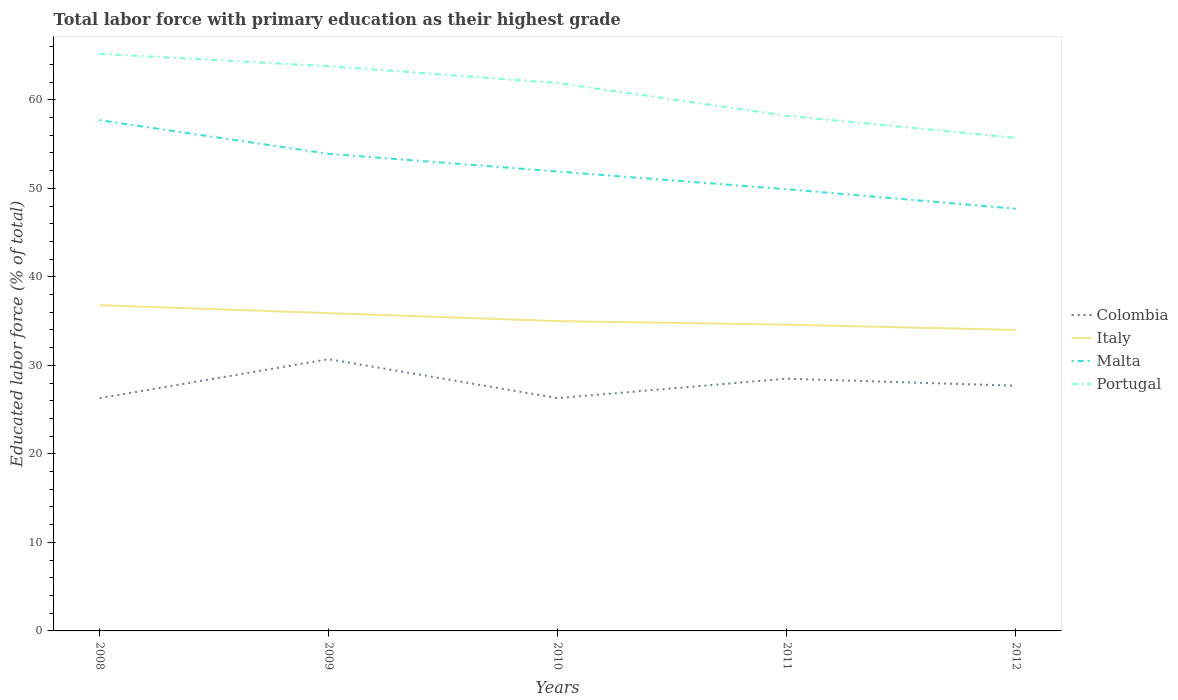How many different coloured lines are there?
Provide a succinct answer. 4. Is the number of lines equal to the number of legend labels?
Your response must be concise. Yes. What is the total percentage of total labor force with primary education in Italy in the graph?
Your response must be concise. 0.9. What is the difference between the highest and the second highest percentage of total labor force with primary education in Italy?
Give a very brief answer. 2.8. What is the difference between two consecutive major ticks on the Y-axis?
Your response must be concise. 10. Does the graph contain any zero values?
Your answer should be very brief. No. Does the graph contain grids?
Provide a succinct answer. No. Where does the legend appear in the graph?
Offer a terse response. Center right. How are the legend labels stacked?
Keep it short and to the point. Vertical. What is the title of the graph?
Keep it short and to the point. Total labor force with primary education as their highest grade. Does "Macao" appear as one of the legend labels in the graph?
Your response must be concise. No. What is the label or title of the Y-axis?
Offer a terse response. Educated labor force (% of total). What is the Educated labor force (% of total) of Colombia in 2008?
Ensure brevity in your answer.  26.3. What is the Educated labor force (% of total) in Italy in 2008?
Provide a short and direct response. 36.8. What is the Educated labor force (% of total) of Malta in 2008?
Offer a very short reply. 57.7. What is the Educated labor force (% of total) in Portugal in 2008?
Your answer should be compact. 65.2. What is the Educated labor force (% of total) of Colombia in 2009?
Ensure brevity in your answer.  30.7. What is the Educated labor force (% of total) of Italy in 2009?
Give a very brief answer. 35.9. What is the Educated labor force (% of total) of Malta in 2009?
Offer a very short reply. 53.9. What is the Educated labor force (% of total) in Portugal in 2009?
Your answer should be very brief. 63.8. What is the Educated labor force (% of total) of Colombia in 2010?
Your answer should be compact. 26.3. What is the Educated labor force (% of total) of Malta in 2010?
Make the answer very short. 51.9. What is the Educated labor force (% of total) of Portugal in 2010?
Provide a succinct answer. 61.9. What is the Educated labor force (% of total) in Italy in 2011?
Your answer should be very brief. 34.6. What is the Educated labor force (% of total) of Malta in 2011?
Make the answer very short. 49.9. What is the Educated labor force (% of total) of Portugal in 2011?
Keep it short and to the point. 58.2. What is the Educated labor force (% of total) in Colombia in 2012?
Your answer should be compact. 27.7. What is the Educated labor force (% of total) of Italy in 2012?
Your answer should be very brief. 34. What is the Educated labor force (% of total) of Malta in 2012?
Provide a short and direct response. 47.7. What is the Educated labor force (% of total) in Portugal in 2012?
Your answer should be compact. 55.7. Across all years, what is the maximum Educated labor force (% of total) of Colombia?
Your answer should be compact. 30.7. Across all years, what is the maximum Educated labor force (% of total) in Italy?
Offer a very short reply. 36.8. Across all years, what is the maximum Educated labor force (% of total) in Malta?
Give a very brief answer. 57.7. Across all years, what is the maximum Educated labor force (% of total) in Portugal?
Ensure brevity in your answer.  65.2. Across all years, what is the minimum Educated labor force (% of total) of Colombia?
Provide a succinct answer. 26.3. Across all years, what is the minimum Educated labor force (% of total) of Italy?
Provide a short and direct response. 34. Across all years, what is the minimum Educated labor force (% of total) of Malta?
Offer a very short reply. 47.7. Across all years, what is the minimum Educated labor force (% of total) in Portugal?
Make the answer very short. 55.7. What is the total Educated labor force (% of total) in Colombia in the graph?
Make the answer very short. 139.5. What is the total Educated labor force (% of total) in Italy in the graph?
Offer a terse response. 176.3. What is the total Educated labor force (% of total) of Malta in the graph?
Offer a terse response. 261.1. What is the total Educated labor force (% of total) of Portugal in the graph?
Make the answer very short. 304.8. What is the difference between the Educated labor force (% of total) in Portugal in 2008 and that in 2009?
Offer a very short reply. 1.4. What is the difference between the Educated labor force (% of total) in Colombia in 2008 and that in 2010?
Give a very brief answer. 0. What is the difference between the Educated labor force (% of total) of Malta in 2008 and that in 2010?
Your answer should be compact. 5.8. What is the difference between the Educated labor force (% of total) of Italy in 2008 and that in 2011?
Offer a terse response. 2.2. What is the difference between the Educated labor force (% of total) of Portugal in 2008 and that in 2011?
Your answer should be compact. 7. What is the difference between the Educated labor force (% of total) in Malta in 2008 and that in 2012?
Your answer should be compact. 10. What is the difference between the Educated labor force (% of total) in Portugal in 2008 and that in 2012?
Your response must be concise. 9.5. What is the difference between the Educated labor force (% of total) of Colombia in 2009 and that in 2010?
Ensure brevity in your answer.  4.4. What is the difference between the Educated labor force (% of total) of Italy in 2009 and that in 2010?
Give a very brief answer. 0.9. What is the difference between the Educated labor force (% of total) in Malta in 2009 and that in 2010?
Your answer should be very brief. 2. What is the difference between the Educated labor force (% of total) of Malta in 2009 and that in 2011?
Your answer should be compact. 4. What is the difference between the Educated labor force (% of total) in Italy in 2009 and that in 2012?
Your response must be concise. 1.9. What is the difference between the Educated labor force (% of total) of Portugal in 2009 and that in 2012?
Keep it short and to the point. 8.1. What is the difference between the Educated labor force (% of total) in Malta in 2010 and that in 2011?
Offer a very short reply. 2. What is the difference between the Educated labor force (% of total) in Portugal in 2010 and that in 2011?
Your answer should be very brief. 3.7. What is the difference between the Educated labor force (% of total) of Italy in 2010 and that in 2012?
Offer a very short reply. 1. What is the difference between the Educated labor force (% of total) in Malta in 2010 and that in 2012?
Your response must be concise. 4.2. What is the difference between the Educated labor force (% of total) of Malta in 2011 and that in 2012?
Your response must be concise. 2.2. What is the difference between the Educated labor force (% of total) in Colombia in 2008 and the Educated labor force (% of total) in Malta in 2009?
Offer a very short reply. -27.6. What is the difference between the Educated labor force (% of total) in Colombia in 2008 and the Educated labor force (% of total) in Portugal in 2009?
Provide a succinct answer. -37.5. What is the difference between the Educated labor force (% of total) of Italy in 2008 and the Educated labor force (% of total) of Malta in 2009?
Keep it short and to the point. -17.1. What is the difference between the Educated labor force (% of total) in Colombia in 2008 and the Educated labor force (% of total) in Malta in 2010?
Provide a succinct answer. -25.6. What is the difference between the Educated labor force (% of total) in Colombia in 2008 and the Educated labor force (% of total) in Portugal in 2010?
Give a very brief answer. -35.6. What is the difference between the Educated labor force (% of total) in Italy in 2008 and the Educated labor force (% of total) in Malta in 2010?
Your response must be concise. -15.1. What is the difference between the Educated labor force (% of total) in Italy in 2008 and the Educated labor force (% of total) in Portugal in 2010?
Your answer should be very brief. -25.1. What is the difference between the Educated labor force (% of total) of Malta in 2008 and the Educated labor force (% of total) of Portugal in 2010?
Offer a terse response. -4.2. What is the difference between the Educated labor force (% of total) in Colombia in 2008 and the Educated labor force (% of total) in Malta in 2011?
Give a very brief answer. -23.6. What is the difference between the Educated labor force (% of total) of Colombia in 2008 and the Educated labor force (% of total) of Portugal in 2011?
Make the answer very short. -31.9. What is the difference between the Educated labor force (% of total) of Italy in 2008 and the Educated labor force (% of total) of Portugal in 2011?
Ensure brevity in your answer.  -21.4. What is the difference between the Educated labor force (% of total) in Colombia in 2008 and the Educated labor force (% of total) in Malta in 2012?
Ensure brevity in your answer.  -21.4. What is the difference between the Educated labor force (% of total) of Colombia in 2008 and the Educated labor force (% of total) of Portugal in 2012?
Provide a short and direct response. -29.4. What is the difference between the Educated labor force (% of total) in Italy in 2008 and the Educated labor force (% of total) in Portugal in 2012?
Keep it short and to the point. -18.9. What is the difference between the Educated labor force (% of total) in Malta in 2008 and the Educated labor force (% of total) in Portugal in 2012?
Ensure brevity in your answer.  2. What is the difference between the Educated labor force (% of total) of Colombia in 2009 and the Educated labor force (% of total) of Italy in 2010?
Provide a succinct answer. -4.3. What is the difference between the Educated labor force (% of total) in Colombia in 2009 and the Educated labor force (% of total) in Malta in 2010?
Offer a terse response. -21.2. What is the difference between the Educated labor force (% of total) in Colombia in 2009 and the Educated labor force (% of total) in Portugal in 2010?
Offer a terse response. -31.2. What is the difference between the Educated labor force (% of total) in Italy in 2009 and the Educated labor force (% of total) in Portugal in 2010?
Give a very brief answer. -26. What is the difference between the Educated labor force (% of total) in Malta in 2009 and the Educated labor force (% of total) in Portugal in 2010?
Your answer should be compact. -8. What is the difference between the Educated labor force (% of total) in Colombia in 2009 and the Educated labor force (% of total) in Malta in 2011?
Offer a very short reply. -19.2. What is the difference between the Educated labor force (% of total) in Colombia in 2009 and the Educated labor force (% of total) in Portugal in 2011?
Keep it short and to the point. -27.5. What is the difference between the Educated labor force (% of total) of Italy in 2009 and the Educated labor force (% of total) of Malta in 2011?
Provide a short and direct response. -14. What is the difference between the Educated labor force (% of total) in Italy in 2009 and the Educated labor force (% of total) in Portugal in 2011?
Offer a very short reply. -22.3. What is the difference between the Educated labor force (% of total) in Colombia in 2009 and the Educated labor force (% of total) in Italy in 2012?
Give a very brief answer. -3.3. What is the difference between the Educated labor force (% of total) in Colombia in 2009 and the Educated labor force (% of total) in Portugal in 2012?
Your response must be concise. -25. What is the difference between the Educated labor force (% of total) in Italy in 2009 and the Educated labor force (% of total) in Portugal in 2012?
Ensure brevity in your answer.  -19.8. What is the difference between the Educated labor force (% of total) of Malta in 2009 and the Educated labor force (% of total) of Portugal in 2012?
Offer a very short reply. -1.8. What is the difference between the Educated labor force (% of total) in Colombia in 2010 and the Educated labor force (% of total) in Italy in 2011?
Your answer should be compact. -8.3. What is the difference between the Educated labor force (% of total) of Colombia in 2010 and the Educated labor force (% of total) of Malta in 2011?
Keep it short and to the point. -23.6. What is the difference between the Educated labor force (% of total) of Colombia in 2010 and the Educated labor force (% of total) of Portugal in 2011?
Your answer should be compact. -31.9. What is the difference between the Educated labor force (% of total) in Italy in 2010 and the Educated labor force (% of total) in Malta in 2011?
Keep it short and to the point. -14.9. What is the difference between the Educated labor force (% of total) of Italy in 2010 and the Educated labor force (% of total) of Portugal in 2011?
Your response must be concise. -23.2. What is the difference between the Educated labor force (% of total) in Malta in 2010 and the Educated labor force (% of total) in Portugal in 2011?
Offer a terse response. -6.3. What is the difference between the Educated labor force (% of total) of Colombia in 2010 and the Educated labor force (% of total) of Malta in 2012?
Give a very brief answer. -21.4. What is the difference between the Educated labor force (% of total) of Colombia in 2010 and the Educated labor force (% of total) of Portugal in 2012?
Your answer should be very brief. -29.4. What is the difference between the Educated labor force (% of total) of Italy in 2010 and the Educated labor force (% of total) of Malta in 2012?
Ensure brevity in your answer.  -12.7. What is the difference between the Educated labor force (% of total) in Italy in 2010 and the Educated labor force (% of total) in Portugal in 2012?
Your response must be concise. -20.7. What is the difference between the Educated labor force (% of total) in Malta in 2010 and the Educated labor force (% of total) in Portugal in 2012?
Provide a succinct answer. -3.8. What is the difference between the Educated labor force (% of total) of Colombia in 2011 and the Educated labor force (% of total) of Italy in 2012?
Give a very brief answer. -5.5. What is the difference between the Educated labor force (% of total) in Colombia in 2011 and the Educated labor force (% of total) in Malta in 2012?
Your answer should be compact. -19.2. What is the difference between the Educated labor force (% of total) of Colombia in 2011 and the Educated labor force (% of total) of Portugal in 2012?
Offer a very short reply. -27.2. What is the difference between the Educated labor force (% of total) in Italy in 2011 and the Educated labor force (% of total) in Malta in 2012?
Your answer should be compact. -13.1. What is the difference between the Educated labor force (% of total) of Italy in 2011 and the Educated labor force (% of total) of Portugal in 2012?
Your answer should be very brief. -21.1. What is the average Educated labor force (% of total) of Colombia per year?
Make the answer very short. 27.9. What is the average Educated labor force (% of total) of Italy per year?
Ensure brevity in your answer.  35.26. What is the average Educated labor force (% of total) in Malta per year?
Offer a terse response. 52.22. What is the average Educated labor force (% of total) of Portugal per year?
Make the answer very short. 60.96. In the year 2008, what is the difference between the Educated labor force (% of total) of Colombia and Educated labor force (% of total) of Italy?
Your answer should be compact. -10.5. In the year 2008, what is the difference between the Educated labor force (% of total) in Colombia and Educated labor force (% of total) in Malta?
Ensure brevity in your answer.  -31.4. In the year 2008, what is the difference between the Educated labor force (% of total) in Colombia and Educated labor force (% of total) in Portugal?
Your response must be concise. -38.9. In the year 2008, what is the difference between the Educated labor force (% of total) of Italy and Educated labor force (% of total) of Malta?
Make the answer very short. -20.9. In the year 2008, what is the difference between the Educated labor force (% of total) in Italy and Educated labor force (% of total) in Portugal?
Make the answer very short. -28.4. In the year 2008, what is the difference between the Educated labor force (% of total) of Malta and Educated labor force (% of total) of Portugal?
Keep it short and to the point. -7.5. In the year 2009, what is the difference between the Educated labor force (% of total) of Colombia and Educated labor force (% of total) of Malta?
Give a very brief answer. -23.2. In the year 2009, what is the difference between the Educated labor force (% of total) in Colombia and Educated labor force (% of total) in Portugal?
Keep it short and to the point. -33.1. In the year 2009, what is the difference between the Educated labor force (% of total) in Italy and Educated labor force (% of total) in Malta?
Make the answer very short. -18. In the year 2009, what is the difference between the Educated labor force (% of total) in Italy and Educated labor force (% of total) in Portugal?
Offer a terse response. -27.9. In the year 2010, what is the difference between the Educated labor force (% of total) of Colombia and Educated labor force (% of total) of Italy?
Your answer should be compact. -8.7. In the year 2010, what is the difference between the Educated labor force (% of total) in Colombia and Educated labor force (% of total) in Malta?
Your response must be concise. -25.6. In the year 2010, what is the difference between the Educated labor force (% of total) in Colombia and Educated labor force (% of total) in Portugal?
Ensure brevity in your answer.  -35.6. In the year 2010, what is the difference between the Educated labor force (% of total) of Italy and Educated labor force (% of total) of Malta?
Ensure brevity in your answer.  -16.9. In the year 2010, what is the difference between the Educated labor force (% of total) in Italy and Educated labor force (% of total) in Portugal?
Make the answer very short. -26.9. In the year 2011, what is the difference between the Educated labor force (% of total) of Colombia and Educated labor force (% of total) of Italy?
Offer a very short reply. -6.1. In the year 2011, what is the difference between the Educated labor force (% of total) in Colombia and Educated labor force (% of total) in Malta?
Make the answer very short. -21.4. In the year 2011, what is the difference between the Educated labor force (% of total) in Colombia and Educated labor force (% of total) in Portugal?
Provide a short and direct response. -29.7. In the year 2011, what is the difference between the Educated labor force (% of total) of Italy and Educated labor force (% of total) of Malta?
Make the answer very short. -15.3. In the year 2011, what is the difference between the Educated labor force (% of total) of Italy and Educated labor force (% of total) of Portugal?
Your answer should be compact. -23.6. In the year 2012, what is the difference between the Educated labor force (% of total) of Italy and Educated labor force (% of total) of Malta?
Your response must be concise. -13.7. In the year 2012, what is the difference between the Educated labor force (% of total) of Italy and Educated labor force (% of total) of Portugal?
Your response must be concise. -21.7. What is the ratio of the Educated labor force (% of total) of Colombia in 2008 to that in 2009?
Provide a short and direct response. 0.86. What is the ratio of the Educated labor force (% of total) in Italy in 2008 to that in 2009?
Provide a succinct answer. 1.03. What is the ratio of the Educated labor force (% of total) in Malta in 2008 to that in 2009?
Your answer should be very brief. 1.07. What is the ratio of the Educated labor force (% of total) of Portugal in 2008 to that in 2009?
Your answer should be compact. 1.02. What is the ratio of the Educated labor force (% of total) of Colombia in 2008 to that in 2010?
Your answer should be very brief. 1. What is the ratio of the Educated labor force (% of total) of Italy in 2008 to that in 2010?
Offer a terse response. 1.05. What is the ratio of the Educated labor force (% of total) of Malta in 2008 to that in 2010?
Your response must be concise. 1.11. What is the ratio of the Educated labor force (% of total) in Portugal in 2008 to that in 2010?
Your answer should be compact. 1.05. What is the ratio of the Educated labor force (% of total) in Colombia in 2008 to that in 2011?
Keep it short and to the point. 0.92. What is the ratio of the Educated labor force (% of total) in Italy in 2008 to that in 2011?
Offer a terse response. 1.06. What is the ratio of the Educated labor force (% of total) of Malta in 2008 to that in 2011?
Make the answer very short. 1.16. What is the ratio of the Educated labor force (% of total) in Portugal in 2008 to that in 2011?
Your response must be concise. 1.12. What is the ratio of the Educated labor force (% of total) of Colombia in 2008 to that in 2012?
Make the answer very short. 0.95. What is the ratio of the Educated labor force (% of total) in Italy in 2008 to that in 2012?
Make the answer very short. 1.08. What is the ratio of the Educated labor force (% of total) in Malta in 2008 to that in 2012?
Offer a very short reply. 1.21. What is the ratio of the Educated labor force (% of total) of Portugal in 2008 to that in 2012?
Your answer should be compact. 1.17. What is the ratio of the Educated labor force (% of total) in Colombia in 2009 to that in 2010?
Provide a succinct answer. 1.17. What is the ratio of the Educated labor force (% of total) of Italy in 2009 to that in 2010?
Give a very brief answer. 1.03. What is the ratio of the Educated labor force (% of total) of Malta in 2009 to that in 2010?
Keep it short and to the point. 1.04. What is the ratio of the Educated labor force (% of total) in Portugal in 2009 to that in 2010?
Provide a short and direct response. 1.03. What is the ratio of the Educated labor force (% of total) of Colombia in 2009 to that in 2011?
Your response must be concise. 1.08. What is the ratio of the Educated labor force (% of total) of Italy in 2009 to that in 2011?
Your answer should be compact. 1.04. What is the ratio of the Educated labor force (% of total) in Malta in 2009 to that in 2011?
Provide a succinct answer. 1.08. What is the ratio of the Educated labor force (% of total) in Portugal in 2009 to that in 2011?
Your response must be concise. 1.1. What is the ratio of the Educated labor force (% of total) in Colombia in 2009 to that in 2012?
Ensure brevity in your answer.  1.11. What is the ratio of the Educated labor force (% of total) in Italy in 2009 to that in 2012?
Your response must be concise. 1.06. What is the ratio of the Educated labor force (% of total) in Malta in 2009 to that in 2012?
Keep it short and to the point. 1.13. What is the ratio of the Educated labor force (% of total) in Portugal in 2009 to that in 2012?
Provide a short and direct response. 1.15. What is the ratio of the Educated labor force (% of total) of Colombia in 2010 to that in 2011?
Provide a succinct answer. 0.92. What is the ratio of the Educated labor force (% of total) of Italy in 2010 to that in 2011?
Give a very brief answer. 1.01. What is the ratio of the Educated labor force (% of total) of Malta in 2010 to that in 2011?
Make the answer very short. 1.04. What is the ratio of the Educated labor force (% of total) in Portugal in 2010 to that in 2011?
Provide a short and direct response. 1.06. What is the ratio of the Educated labor force (% of total) of Colombia in 2010 to that in 2012?
Offer a very short reply. 0.95. What is the ratio of the Educated labor force (% of total) of Italy in 2010 to that in 2012?
Your response must be concise. 1.03. What is the ratio of the Educated labor force (% of total) in Malta in 2010 to that in 2012?
Make the answer very short. 1.09. What is the ratio of the Educated labor force (% of total) of Portugal in 2010 to that in 2012?
Your response must be concise. 1.11. What is the ratio of the Educated labor force (% of total) of Colombia in 2011 to that in 2012?
Offer a terse response. 1.03. What is the ratio of the Educated labor force (% of total) of Italy in 2011 to that in 2012?
Make the answer very short. 1.02. What is the ratio of the Educated labor force (% of total) in Malta in 2011 to that in 2012?
Provide a short and direct response. 1.05. What is the ratio of the Educated labor force (% of total) in Portugal in 2011 to that in 2012?
Your answer should be compact. 1.04. What is the difference between the highest and the second highest Educated labor force (% of total) in Colombia?
Your response must be concise. 2.2. What is the difference between the highest and the lowest Educated labor force (% of total) of Malta?
Ensure brevity in your answer.  10. What is the difference between the highest and the lowest Educated labor force (% of total) in Portugal?
Ensure brevity in your answer.  9.5. 